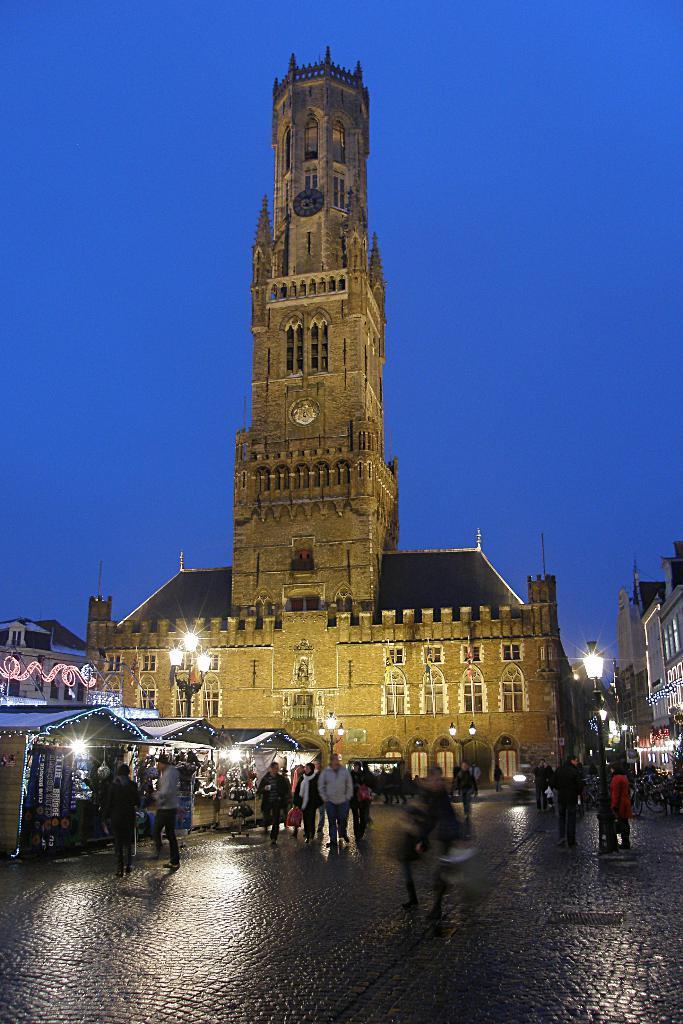How would you summarize this image in a sentence or two? In the center of the image there is a clock tower. At the bottom of the image we can see stalls, persons walking on the road, street lights and buildings. In the background there is a sky. 